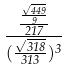<formula> <loc_0><loc_0><loc_500><loc_500>\frac { \frac { \frac { \sqrt { 4 4 9 } } { 9 } } { 2 1 7 } } { ( \frac { \sqrt { 3 1 8 } } { 3 1 3 } ) ^ { 3 } }</formula> 